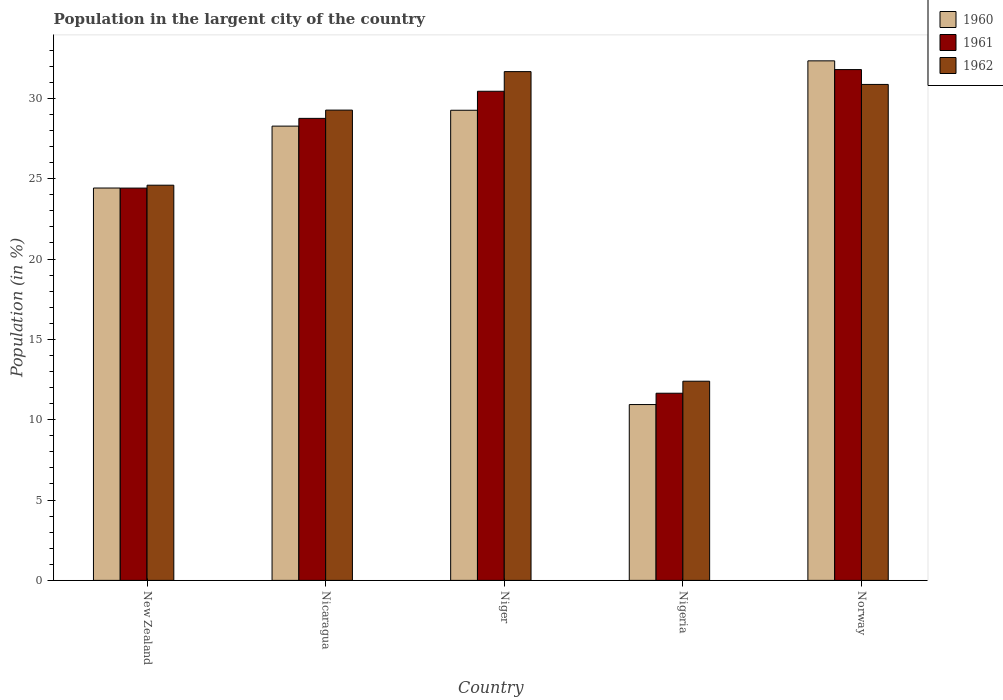How many different coloured bars are there?
Offer a very short reply. 3. Are the number of bars per tick equal to the number of legend labels?
Offer a terse response. Yes. Are the number of bars on each tick of the X-axis equal?
Your answer should be very brief. Yes. How many bars are there on the 2nd tick from the left?
Your answer should be very brief. 3. What is the label of the 1st group of bars from the left?
Make the answer very short. New Zealand. In how many cases, is the number of bars for a given country not equal to the number of legend labels?
Your answer should be very brief. 0. What is the percentage of population in the largent city in 1962 in New Zealand?
Make the answer very short. 24.6. Across all countries, what is the maximum percentage of population in the largent city in 1962?
Your answer should be compact. 31.66. Across all countries, what is the minimum percentage of population in the largent city in 1960?
Provide a succinct answer. 10.94. In which country was the percentage of population in the largent city in 1962 maximum?
Your response must be concise. Niger. In which country was the percentage of population in the largent city in 1960 minimum?
Offer a terse response. Nigeria. What is the total percentage of population in the largent city in 1962 in the graph?
Your answer should be compact. 128.79. What is the difference between the percentage of population in the largent city in 1962 in New Zealand and that in Nigeria?
Ensure brevity in your answer.  12.2. What is the difference between the percentage of population in the largent city in 1962 in Nigeria and the percentage of population in the largent city in 1960 in Norway?
Your answer should be compact. -19.94. What is the average percentage of population in the largent city in 1961 per country?
Make the answer very short. 25.41. What is the difference between the percentage of population in the largent city of/in 1962 and percentage of population in the largent city of/in 1961 in Nicaragua?
Make the answer very short. 0.51. In how many countries, is the percentage of population in the largent city in 1962 greater than 4 %?
Give a very brief answer. 5. What is the ratio of the percentage of population in the largent city in 1961 in Nicaragua to that in Nigeria?
Offer a terse response. 2.47. Is the difference between the percentage of population in the largent city in 1962 in New Zealand and Niger greater than the difference between the percentage of population in the largent city in 1961 in New Zealand and Niger?
Give a very brief answer. No. What is the difference between the highest and the second highest percentage of population in the largent city in 1962?
Give a very brief answer. -1.6. What is the difference between the highest and the lowest percentage of population in the largent city in 1962?
Offer a very short reply. 19.27. Is the sum of the percentage of population in the largent city in 1961 in New Zealand and Niger greater than the maximum percentage of population in the largent city in 1962 across all countries?
Your answer should be compact. Yes. Is it the case that in every country, the sum of the percentage of population in the largent city in 1962 and percentage of population in the largent city in 1961 is greater than the percentage of population in the largent city in 1960?
Give a very brief answer. Yes. How many bars are there?
Provide a succinct answer. 15. Are all the bars in the graph horizontal?
Your answer should be compact. No. How many countries are there in the graph?
Offer a terse response. 5. Where does the legend appear in the graph?
Keep it short and to the point. Top right. How many legend labels are there?
Provide a short and direct response. 3. How are the legend labels stacked?
Keep it short and to the point. Vertical. What is the title of the graph?
Make the answer very short. Population in the largent city of the country. Does "1982" appear as one of the legend labels in the graph?
Provide a short and direct response. No. What is the label or title of the X-axis?
Your answer should be compact. Country. What is the Population (in %) in 1960 in New Zealand?
Ensure brevity in your answer.  24.42. What is the Population (in %) in 1961 in New Zealand?
Keep it short and to the point. 24.41. What is the Population (in %) of 1962 in New Zealand?
Provide a succinct answer. 24.6. What is the Population (in %) in 1960 in Nicaragua?
Your response must be concise. 28.27. What is the Population (in %) in 1961 in Nicaragua?
Make the answer very short. 28.75. What is the Population (in %) in 1962 in Nicaragua?
Give a very brief answer. 29.27. What is the Population (in %) of 1960 in Niger?
Ensure brevity in your answer.  29.26. What is the Population (in %) of 1961 in Niger?
Keep it short and to the point. 30.44. What is the Population (in %) in 1962 in Niger?
Provide a short and direct response. 31.66. What is the Population (in %) in 1960 in Nigeria?
Ensure brevity in your answer.  10.94. What is the Population (in %) in 1961 in Nigeria?
Ensure brevity in your answer.  11.65. What is the Population (in %) of 1962 in Nigeria?
Make the answer very short. 12.4. What is the Population (in %) of 1960 in Norway?
Ensure brevity in your answer.  32.33. What is the Population (in %) in 1961 in Norway?
Provide a succinct answer. 31.79. What is the Population (in %) in 1962 in Norway?
Ensure brevity in your answer.  30.87. Across all countries, what is the maximum Population (in %) in 1960?
Ensure brevity in your answer.  32.33. Across all countries, what is the maximum Population (in %) of 1961?
Your answer should be compact. 31.79. Across all countries, what is the maximum Population (in %) of 1962?
Your response must be concise. 31.66. Across all countries, what is the minimum Population (in %) in 1960?
Offer a very short reply. 10.94. Across all countries, what is the minimum Population (in %) of 1961?
Offer a terse response. 11.65. Across all countries, what is the minimum Population (in %) in 1962?
Keep it short and to the point. 12.4. What is the total Population (in %) of 1960 in the graph?
Make the answer very short. 125.23. What is the total Population (in %) in 1961 in the graph?
Keep it short and to the point. 127.05. What is the total Population (in %) in 1962 in the graph?
Keep it short and to the point. 128.79. What is the difference between the Population (in %) in 1960 in New Zealand and that in Nicaragua?
Provide a short and direct response. -3.85. What is the difference between the Population (in %) in 1961 in New Zealand and that in Nicaragua?
Your answer should be very brief. -4.34. What is the difference between the Population (in %) in 1962 in New Zealand and that in Nicaragua?
Provide a short and direct response. -4.67. What is the difference between the Population (in %) of 1960 in New Zealand and that in Niger?
Give a very brief answer. -4.84. What is the difference between the Population (in %) of 1961 in New Zealand and that in Niger?
Ensure brevity in your answer.  -6.03. What is the difference between the Population (in %) in 1962 in New Zealand and that in Niger?
Your answer should be compact. -7.07. What is the difference between the Population (in %) of 1960 in New Zealand and that in Nigeria?
Provide a short and direct response. 13.48. What is the difference between the Population (in %) in 1961 in New Zealand and that in Nigeria?
Provide a short and direct response. 12.77. What is the difference between the Population (in %) of 1962 in New Zealand and that in Nigeria?
Give a very brief answer. 12.2. What is the difference between the Population (in %) of 1960 in New Zealand and that in Norway?
Give a very brief answer. -7.91. What is the difference between the Population (in %) of 1961 in New Zealand and that in Norway?
Provide a short and direct response. -7.38. What is the difference between the Population (in %) in 1962 in New Zealand and that in Norway?
Your answer should be compact. -6.27. What is the difference between the Population (in %) of 1960 in Nicaragua and that in Niger?
Offer a terse response. -0.99. What is the difference between the Population (in %) of 1961 in Nicaragua and that in Niger?
Ensure brevity in your answer.  -1.69. What is the difference between the Population (in %) in 1962 in Nicaragua and that in Niger?
Offer a terse response. -2.4. What is the difference between the Population (in %) in 1960 in Nicaragua and that in Nigeria?
Provide a short and direct response. 17.33. What is the difference between the Population (in %) of 1961 in Nicaragua and that in Nigeria?
Provide a short and direct response. 17.11. What is the difference between the Population (in %) in 1962 in Nicaragua and that in Nigeria?
Provide a succinct answer. 16.87. What is the difference between the Population (in %) of 1960 in Nicaragua and that in Norway?
Your answer should be compact. -4.06. What is the difference between the Population (in %) in 1961 in Nicaragua and that in Norway?
Your answer should be very brief. -3.04. What is the difference between the Population (in %) in 1962 in Nicaragua and that in Norway?
Keep it short and to the point. -1.6. What is the difference between the Population (in %) of 1960 in Niger and that in Nigeria?
Ensure brevity in your answer.  18.32. What is the difference between the Population (in %) of 1961 in Niger and that in Nigeria?
Offer a terse response. 18.79. What is the difference between the Population (in %) in 1962 in Niger and that in Nigeria?
Make the answer very short. 19.27. What is the difference between the Population (in %) of 1960 in Niger and that in Norway?
Your response must be concise. -3.07. What is the difference between the Population (in %) in 1961 in Niger and that in Norway?
Keep it short and to the point. -1.35. What is the difference between the Population (in %) of 1962 in Niger and that in Norway?
Make the answer very short. 0.8. What is the difference between the Population (in %) in 1960 in Nigeria and that in Norway?
Your response must be concise. -21.39. What is the difference between the Population (in %) in 1961 in Nigeria and that in Norway?
Offer a very short reply. -20.14. What is the difference between the Population (in %) in 1962 in Nigeria and that in Norway?
Give a very brief answer. -18.47. What is the difference between the Population (in %) of 1960 in New Zealand and the Population (in %) of 1961 in Nicaragua?
Your response must be concise. -4.33. What is the difference between the Population (in %) of 1960 in New Zealand and the Population (in %) of 1962 in Nicaragua?
Ensure brevity in your answer.  -4.85. What is the difference between the Population (in %) in 1961 in New Zealand and the Population (in %) in 1962 in Nicaragua?
Give a very brief answer. -4.85. What is the difference between the Population (in %) of 1960 in New Zealand and the Population (in %) of 1961 in Niger?
Provide a short and direct response. -6.02. What is the difference between the Population (in %) of 1960 in New Zealand and the Population (in %) of 1962 in Niger?
Offer a very short reply. -7.24. What is the difference between the Population (in %) of 1961 in New Zealand and the Population (in %) of 1962 in Niger?
Your answer should be compact. -7.25. What is the difference between the Population (in %) of 1960 in New Zealand and the Population (in %) of 1961 in Nigeria?
Offer a terse response. 12.77. What is the difference between the Population (in %) in 1960 in New Zealand and the Population (in %) in 1962 in Nigeria?
Your answer should be very brief. 12.02. What is the difference between the Population (in %) in 1961 in New Zealand and the Population (in %) in 1962 in Nigeria?
Your answer should be very brief. 12.02. What is the difference between the Population (in %) of 1960 in New Zealand and the Population (in %) of 1961 in Norway?
Your response must be concise. -7.37. What is the difference between the Population (in %) in 1960 in New Zealand and the Population (in %) in 1962 in Norway?
Your answer should be very brief. -6.45. What is the difference between the Population (in %) of 1961 in New Zealand and the Population (in %) of 1962 in Norway?
Give a very brief answer. -6.45. What is the difference between the Population (in %) in 1960 in Nicaragua and the Population (in %) in 1961 in Niger?
Your response must be concise. -2.17. What is the difference between the Population (in %) of 1960 in Nicaragua and the Population (in %) of 1962 in Niger?
Keep it short and to the point. -3.39. What is the difference between the Population (in %) of 1961 in Nicaragua and the Population (in %) of 1962 in Niger?
Your response must be concise. -2.91. What is the difference between the Population (in %) in 1960 in Nicaragua and the Population (in %) in 1961 in Nigeria?
Give a very brief answer. 16.62. What is the difference between the Population (in %) of 1960 in Nicaragua and the Population (in %) of 1962 in Nigeria?
Keep it short and to the point. 15.88. What is the difference between the Population (in %) in 1961 in Nicaragua and the Population (in %) in 1962 in Nigeria?
Your answer should be very brief. 16.36. What is the difference between the Population (in %) in 1960 in Nicaragua and the Population (in %) in 1961 in Norway?
Give a very brief answer. -3.52. What is the difference between the Population (in %) in 1960 in Nicaragua and the Population (in %) in 1962 in Norway?
Provide a succinct answer. -2.59. What is the difference between the Population (in %) in 1961 in Nicaragua and the Population (in %) in 1962 in Norway?
Offer a very short reply. -2.11. What is the difference between the Population (in %) of 1960 in Niger and the Population (in %) of 1961 in Nigeria?
Ensure brevity in your answer.  17.61. What is the difference between the Population (in %) in 1960 in Niger and the Population (in %) in 1962 in Nigeria?
Keep it short and to the point. 16.86. What is the difference between the Population (in %) of 1961 in Niger and the Population (in %) of 1962 in Nigeria?
Provide a short and direct response. 18.04. What is the difference between the Population (in %) of 1960 in Niger and the Population (in %) of 1961 in Norway?
Your answer should be compact. -2.53. What is the difference between the Population (in %) of 1960 in Niger and the Population (in %) of 1962 in Norway?
Give a very brief answer. -1.61. What is the difference between the Population (in %) of 1961 in Niger and the Population (in %) of 1962 in Norway?
Keep it short and to the point. -0.43. What is the difference between the Population (in %) of 1960 in Nigeria and the Population (in %) of 1961 in Norway?
Keep it short and to the point. -20.85. What is the difference between the Population (in %) in 1960 in Nigeria and the Population (in %) in 1962 in Norway?
Provide a short and direct response. -19.92. What is the difference between the Population (in %) of 1961 in Nigeria and the Population (in %) of 1962 in Norway?
Your answer should be compact. -19.22. What is the average Population (in %) in 1960 per country?
Make the answer very short. 25.05. What is the average Population (in %) in 1961 per country?
Keep it short and to the point. 25.41. What is the average Population (in %) of 1962 per country?
Provide a succinct answer. 25.76. What is the difference between the Population (in %) of 1960 and Population (in %) of 1961 in New Zealand?
Your answer should be compact. 0. What is the difference between the Population (in %) in 1960 and Population (in %) in 1962 in New Zealand?
Provide a succinct answer. -0.18. What is the difference between the Population (in %) in 1961 and Population (in %) in 1962 in New Zealand?
Ensure brevity in your answer.  -0.18. What is the difference between the Population (in %) of 1960 and Population (in %) of 1961 in Nicaragua?
Offer a very short reply. -0.48. What is the difference between the Population (in %) of 1960 and Population (in %) of 1962 in Nicaragua?
Your answer should be very brief. -1. What is the difference between the Population (in %) in 1961 and Population (in %) in 1962 in Nicaragua?
Provide a succinct answer. -0.51. What is the difference between the Population (in %) of 1960 and Population (in %) of 1961 in Niger?
Provide a short and direct response. -1.18. What is the difference between the Population (in %) in 1960 and Population (in %) in 1962 in Niger?
Make the answer very short. -2.4. What is the difference between the Population (in %) of 1961 and Population (in %) of 1962 in Niger?
Make the answer very short. -1.22. What is the difference between the Population (in %) of 1960 and Population (in %) of 1961 in Nigeria?
Provide a short and direct response. -0.71. What is the difference between the Population (in %) of 1960 and Population (in %) of 1962 in Nigeria?
Your answer should be compact. -1.45. What is the difference between the Population (in %) of 1961 and Population (in %) of 1962 in Nigeria?
Make the answer very short. -0.75. What is the difference between the Population (in %) of 1960 and Population (in %) of 1961 in Norway?
Ensure brevity in your answer.  0.54. What is the difference between the Population (in %) in 1960 and Population (in %) in 1962 in Norway?
Give a very brief answer. 1.47. What is the difference between the Population (in %) in 1961 and Population (in %) in 1962 in Norway?
Provide a short and direct response. 0.92. What is the ratio of the Population (in %) of 1960 in New Zealand to that in Nicaragua?
Your response must be concise. 0.86. What is the ratio of the Population (in %) of 1961 in New Zealand to that in Nicaragua?
Provide a short and direct response. 0.85. What is the ratio of the Population (in %) in 1962 in New Zealand to that in Nicaragua?
Ensure brevity in your answer.  0.84. What is the ratio of the Population (in %) of 1960 in New Zealand to that in Niger?
Ensure brevity in your answer.  0.83. What is the ratio of the Population (in %) in 1961 in New Zealand to that in Niger?
Offer a terse response. 0.8. What is the ratio of the Population (in %) of 1962 in New Zealand to that in Niger?
Offer a terse response. 0.78. What is the ratio of the Population (in %) in 1960 in New Zealand to that in Nigeria?
Provide a succinct answer. 2.23. What is the ratio of the Population (in %) in 1961 in New Zealand to that in Nigeria?
Keep it short and to the point. 2.1. What is the ratio of the Population (in %) in 1962 in New Zealand to that in Nigeria?
Provide a short and direct response. 1.98. What is the ratio of the Population (in %) of 1960 in New Zealand to that in Norway?
Offer a terse response. 0.76. What is the ratio of the Population (in %) of 1961 in New Zealand to that in Norway?
Ensure brevity in your answer.  0.77. What is the ratio of the Population (in %) of 1962 in New Zealand to that in Norway?
Your answer should be very brief. 0.8. What is the ratio of the Population (in %) in 1960 in Nicaragua to that in Niger?
Make the answer very short. 0.97. What is the ratio of the Population (in %) of 1961 in Nicaragua to that in Niger?
Keep it short and to the point. 0.94. What is the ratio of the Population (in %) of 1962 in Nicaragua to that in Niger?
Make the answer very short. 0.92. What is the ratio of the Population (in %) of 1960 in Nicaragua to that in Nigeria?
Offer a terse response. 2.58. What is the ratio of the Population (in %) in 1961 in Nicaragua to that in Nigeria?
Keep it short and to the point. 2.47. What is the ratio of the Population (in %) in 1962 in Nicaragua to that in Nigeria?
Offer a very short reply. 2.36. What is the ratio of the Population (in %) in 1960 in Nicaragua to that in Norway?
Give a very brief answer. 0.87. What is the ratio of the Population (in %) in 1961 in Nicaragua to that in Norway?
Keep it short and to the point. 0.9. What is the ratio of the Population (in %) of 1962 in Nicaragua to that in Norway?
Offer a very short reply. 0.95. What is the ratio of the Population (in %) of 1960 in Niger to that in Nigeria?
Offer a very short reply. 2.67. What is the ratio of the Population (in %) in 1961 in Niger to that in Nigeria?
Provide a succinct answer. 2.61. What is the ratio of the Population (in %) in 1962 in Niger to that in Nigeria?
Offer a very short reply. 2.55. What is the ratio of the Population (in %) in 1960 in Niger to that in Norway?
Ensure brevity in your answer.  0.9. What is the ratio of the Population (in %) of 1961 in Niger to that in Norway?
Give a very brief answer. 0.96. What is the ratio of the Population (in %) of 1962 in Niger to that in Norway?
Offer a terse response. 1.03. What is the ratio of the Population (in %) of 1960 in Nigeria to that in Norway?
Ensure brevity in your answer.  0.34. What is the ratio of the Population (in %) of 1961 in Nigeria to that in Norway?
Ensure brevity in your answer.  0.37. What is the ratio of the Population (in %) in 1962 in Nigeria to that in Norway?
Make the answer very short. 0.4. What is the difference between the highest and the second highest Population (in %) in 1960?
Provide a succinct answer. 3.07. What is the difference between the highest and the second highest Population (in %) of 1961?
Offer a very short reply. 1.35. What is the difference between the highest and the second highest Population (in %) in 1962?
Provide a short and direct response. 0.8. What is the difference between the highest and the lowest Population (in %) in 1960?
Your answer should be compact. 21.39. What is the difference between the highest and the lowest Population (in %) in 1961?
Make the answer very short. 20.14. What is the difference between the highest and the lowest Population (in %) in 1962?
Your response must be concise. 19.27. 